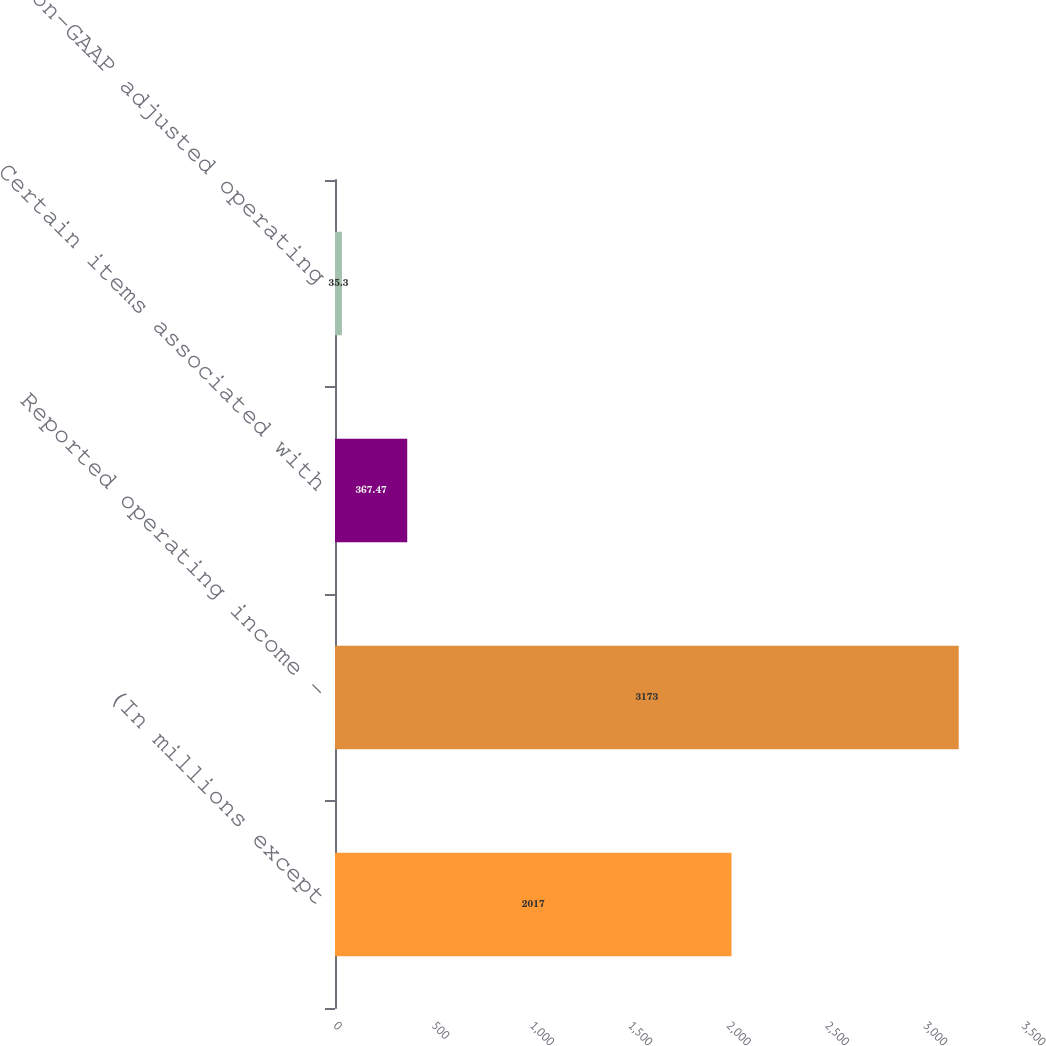<chart> <loc_0><loc_0><loc_500><loc_500><bar_chart><fcel>(In millions except<fcel>Reported operating income -<fcel>Certain items associated with<fcel>Non-GAAP adjusted operating<nl><fcel>2017<fcel>3173<fcel>367.47<fcel>35.3<nl></chart> 